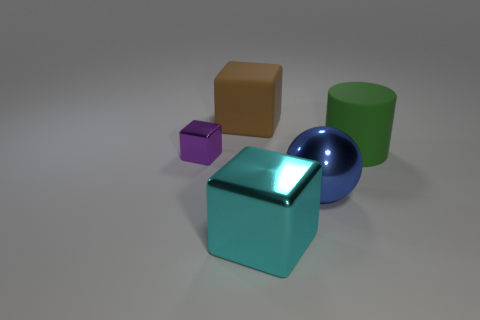Subtract all large blocks. How many blocks are left? 1 Add 1 cyan metallic blocks. How many objects exist? 6 Subtract all cylinders. How many objects are left? 4 Subtract 2 cubes. How many cubes are left? 1 Subtract all purple blocks. How many blocks are left? 2 Subtract all green blocks. Subtract all brown balls. How many blocks are left? 3 Subtract all purple spheres. How many cyan blocks are left? 1 Subtract all tiny yellow objects. Subtract all tiny purple things. How many objects are left? 4 Add 1 big brown cubes. How many big brown cubes are left? 2 Add 5 spheres. How many spheres exist? 6 